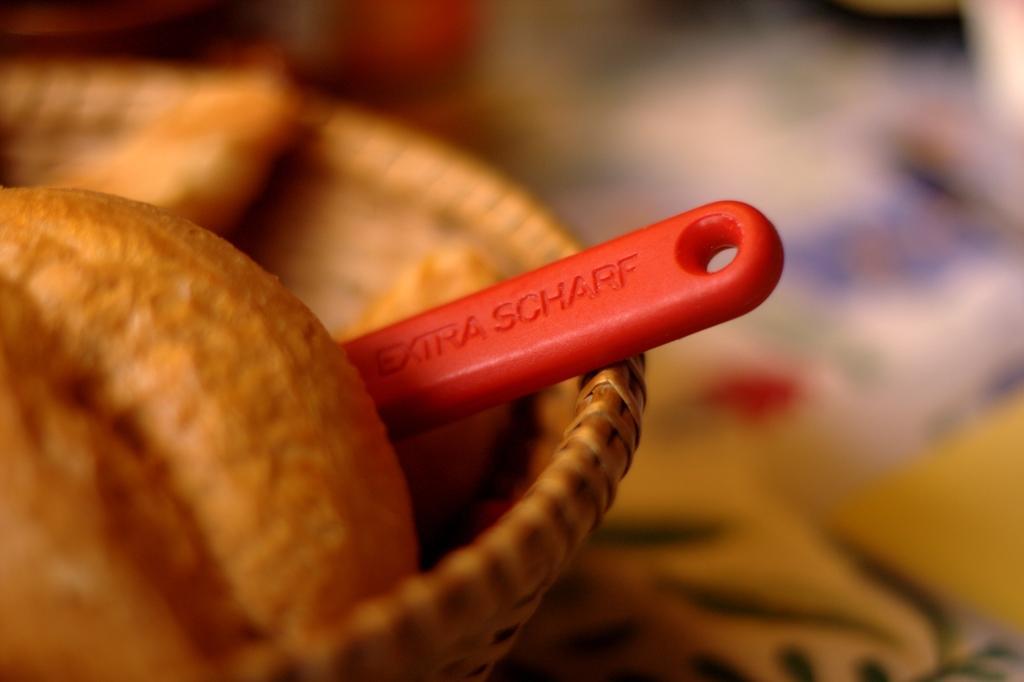Could you give a brief overview of what you see in this image? In this picture there is food and there might be spoon in the basket and there is text on the spoon. Right side of the image is blurry. 